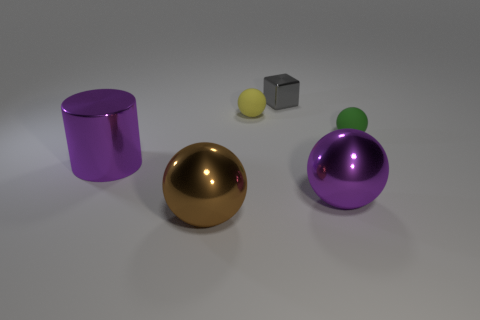Subtract all purple shiny spheres. How many spheres are left? 3 Subtract 1 balls. How many balls are left? 3 Add 2 gray cubes. How many objects exist? 8 Subtract all purple spheres. How many spheres are left? 3 Subtract all balls. How many objects are left? 2 Subtract all green balls. Subtract all blue cylinders. How many balls are left? 3 Subtract all metal things. Subtract all tiny metal objects. How many objects are left? 1 Add 4 yellow rubber things. How many yellow rubber things are left? 5 Add 4 gray metallic blocks. How many gray metallic blocks exist? 5 Subtract 0 brown cylinders. How many objects are left? 6 